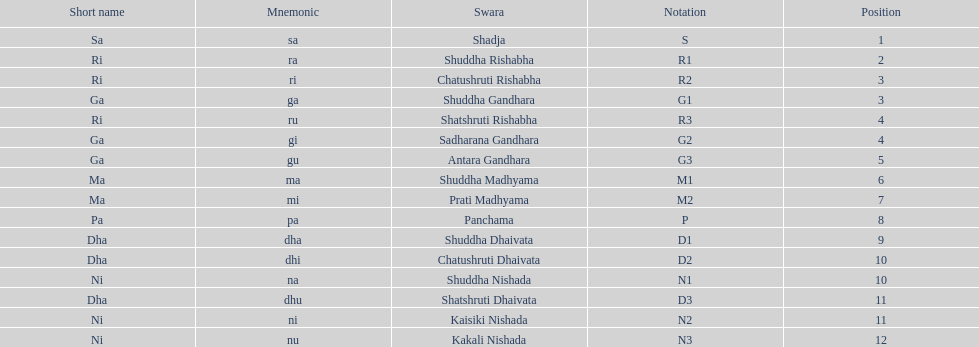What is the appellation of the swara that takes the primary position? Shadja. 